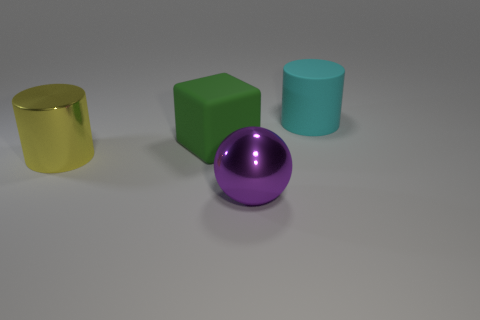There is a matte thing that is left of the shiny object that is right of the cylinder left of the big cyan matte cylinder; what size is it? The object being referred to is the green cube, which is situated to the left of the shiny purple sphere, that in turn is to the right of the small matte blue cylinder which is adjacent to the large cyan matte cylinder. The size of the green cube in comparison to the other objects in the image is medium. 